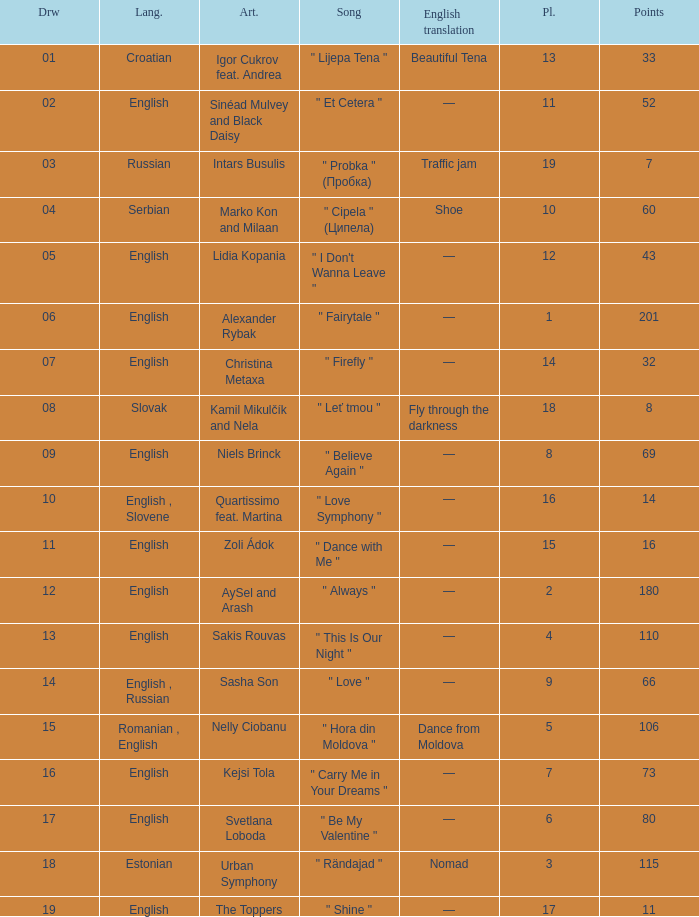What is the english translation when the language is english, draw is smaller than 16, and the artist is aysel and arash? —. 